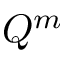Convert formula to latex. <formula><loc_0><loc_0><loc_500><loc_500>Q ^ { m }</formula> 